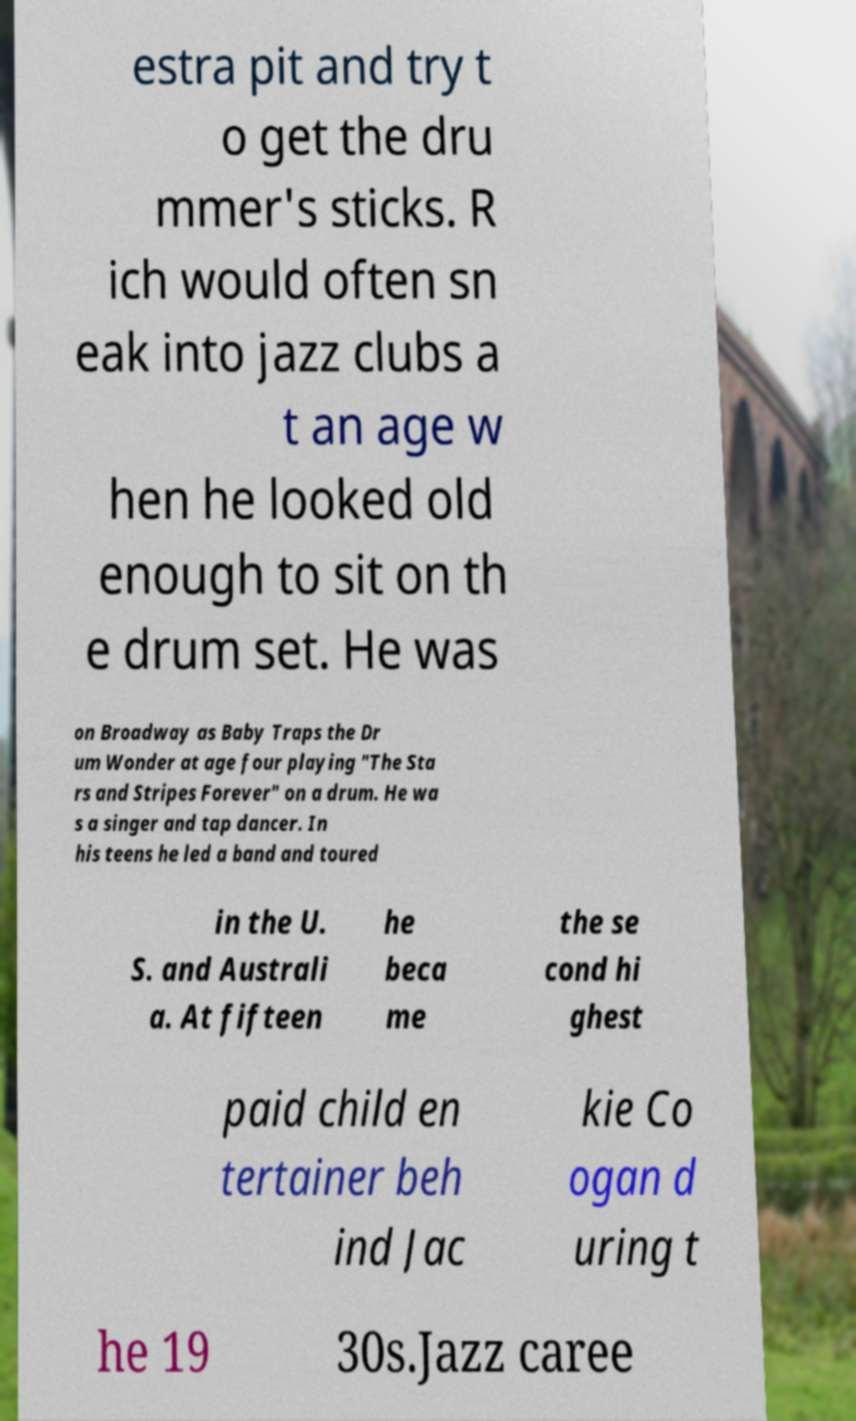For documentation purposes, I need the text within this image transcribed. Could you provide that? estra pit and try t o get the dru mmer's sticks. R ich would often sn eak into jazz clubs a t an age w hen he looked old enough to sit on th e drum set. He was on Broadway as Baby Traps the Dr um Wonder at age four playing "The Sta rs and Stripes Forever" on a drum. He wa s a singer and tap dancer. In his teens he led a band and toured in the U. S. and Australi a. At fifteen he beca me the se cond hi ghest paid child en tertainer beh ind Jac kie Co ogan d uring t he 19 30s.Jazz caree 